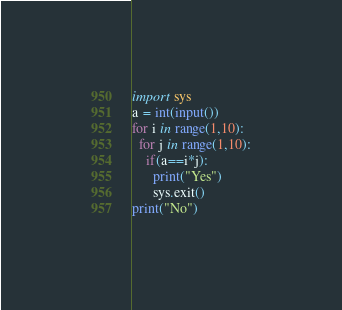<code> <loc_0><loc_0><loc_500><loc_500><_Python_>import sys
a = int(input())
for i in range(1,10):
  for j in range(1,10):
    if(a==i*j):
      print("Yes")
      sys.exit()
print("No")</code> 